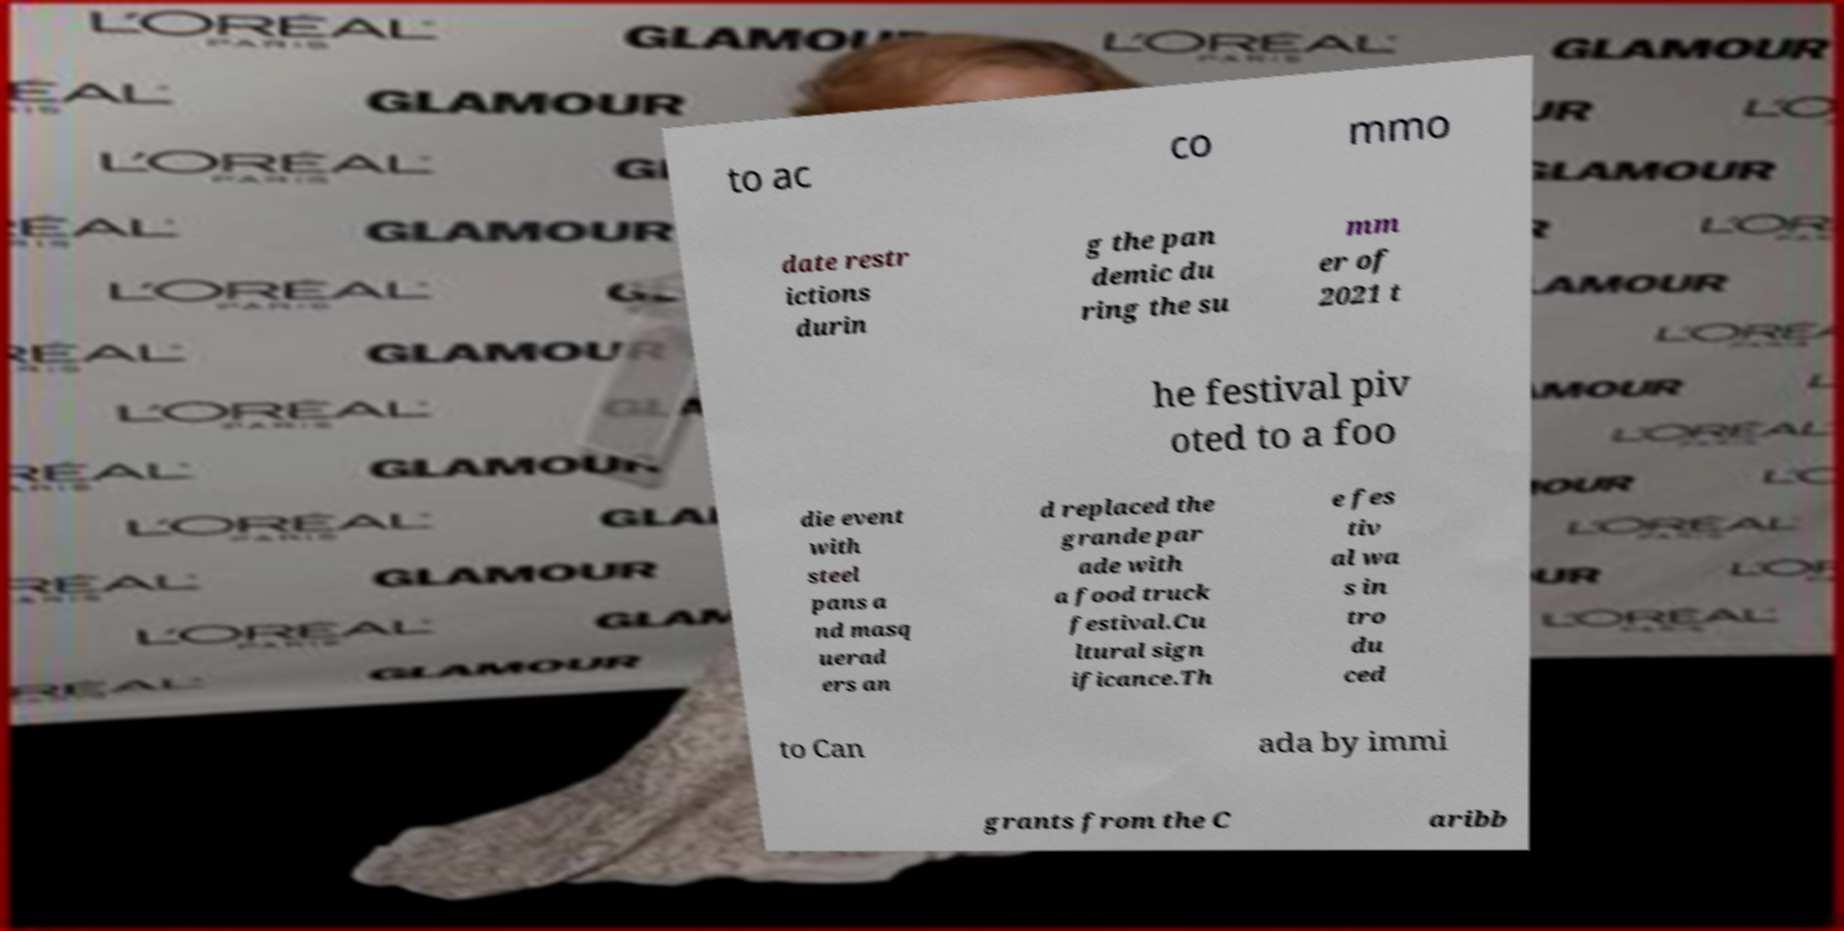Please read and relay the text visible in this image. What does it say? to ac co mmo date restr ictions durin g the pan demic du ring the su mm er of 2021 t he festival piv oted to a foo die event with steel pans a nd masq uerad ers an d replaced the grande par ade with a food truck festival.Cu ltural sign ificance.Th e fes tiv al wa s in tro du ced to Can ada by immi grants from the C aribb 